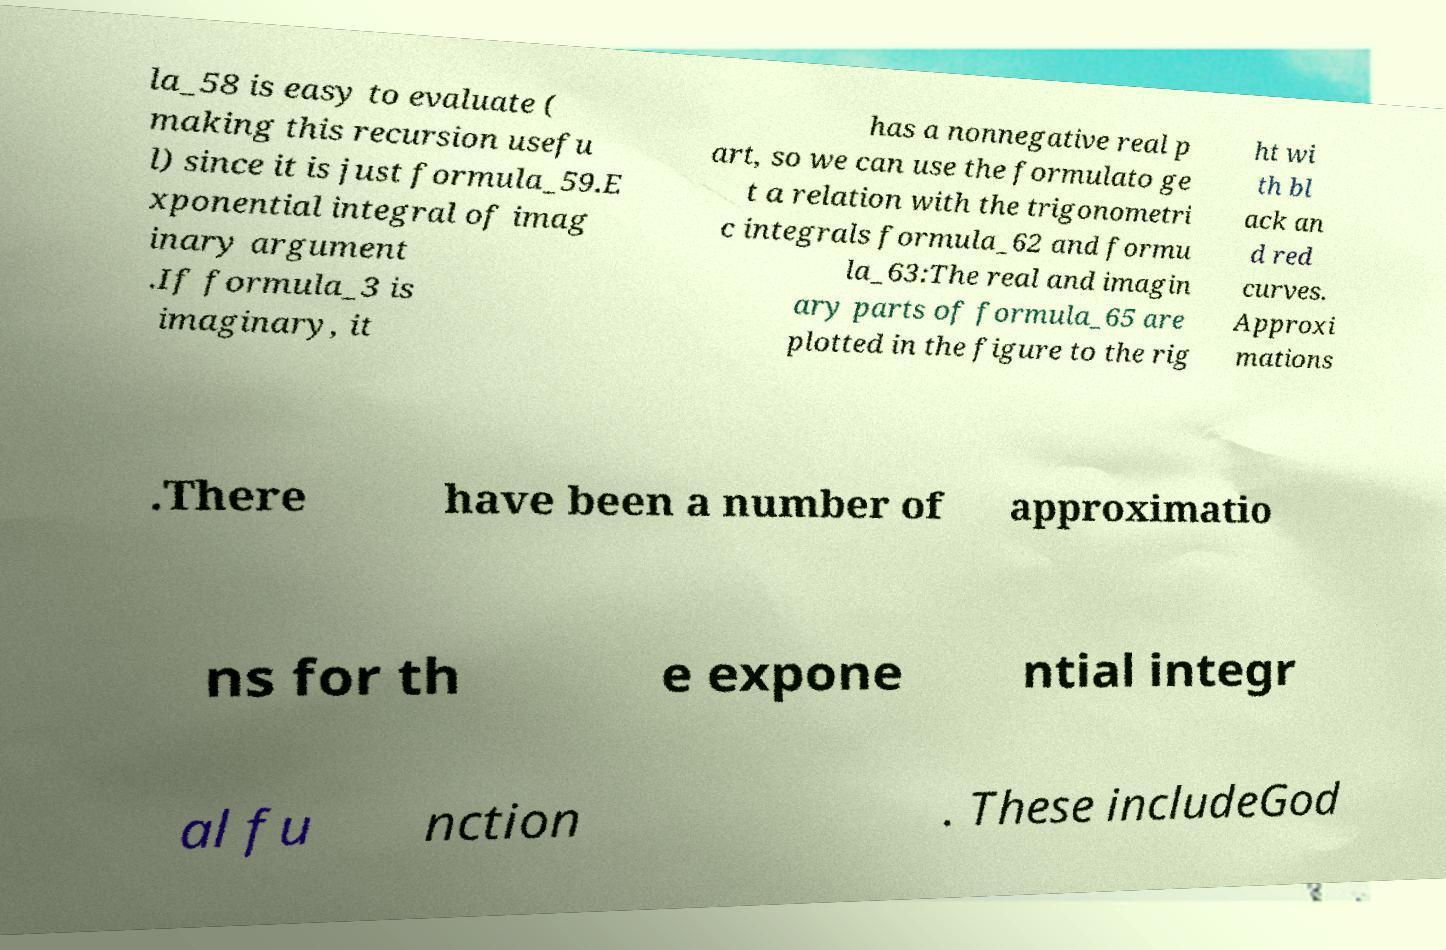There's text embedded in this image that I need extracted. Can you transcribe it verbatim? la_58 is easy to evaluate ( making this recursion usefu l) since it is just formula_59.E xponential integral of imag inary argument .If formula_3 is imaginary, it has a nonnegative real p art, so we can use the formulato ge t a relation with the trigonometri c integrals formula_62 and formu la_63:The real and imagin ary parts of formula_65 are plotted in the figure to the rig ht wi th bl ack an d red curves. Approxi mations .There have been a number of approximatio ns for th e expone ntial integr al fu nction . These includeGod 